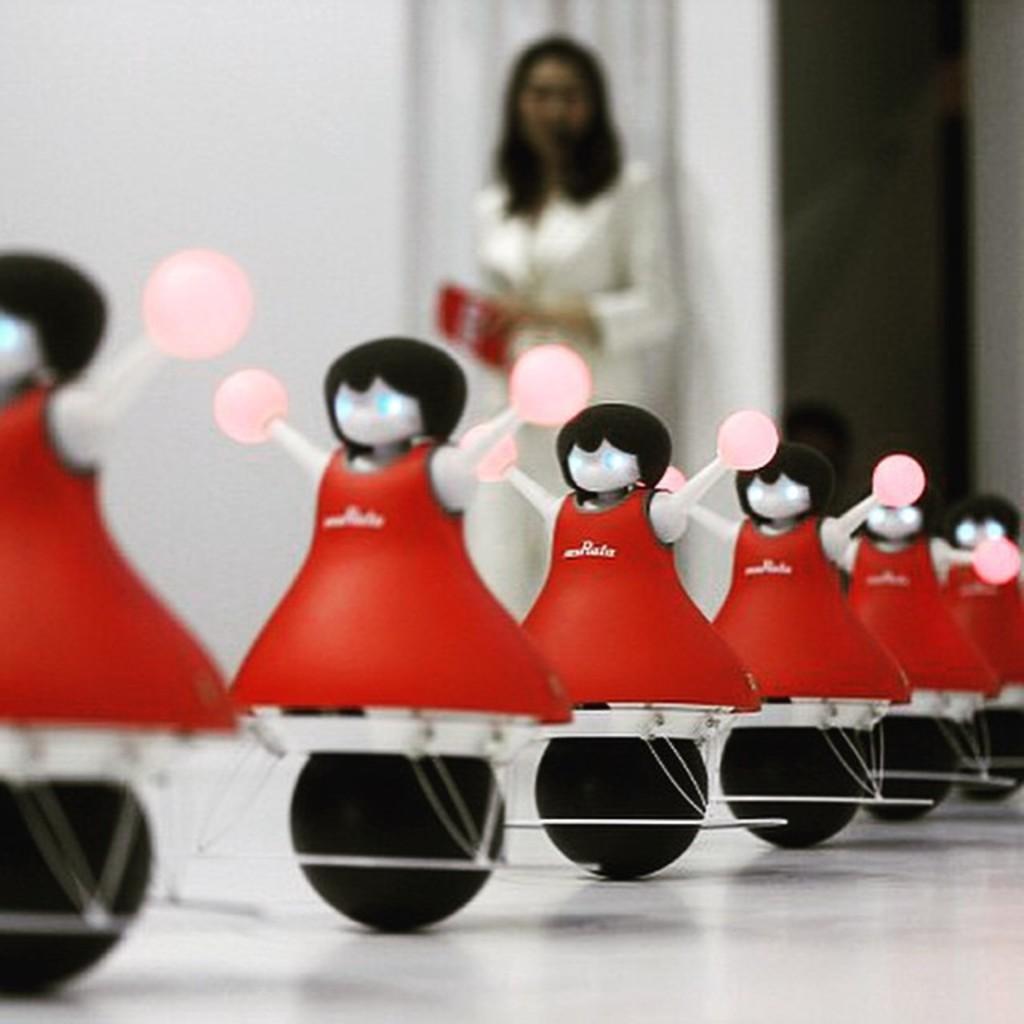Please provide a concise description of this image. In the foreground of this image, there are toys on the white surface. In the background, there is a woman standing holding an object near a wall. 